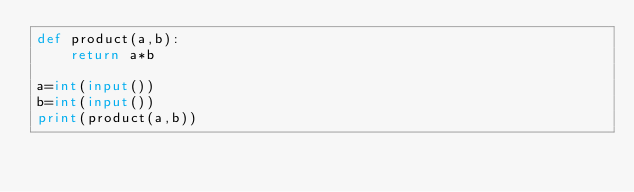Convert code to text. <code><loc_0><loc_0><loc_500><loc_500><_Python_>def product(a,b):
    return a*b
    
a=int(input())
b=int(input())
print(product(a,b))</code> 